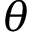<formula> <loc_0><loc_0><loc_500><loc_500>\theta</formula> 